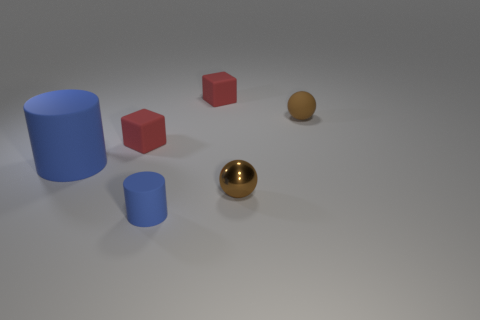Add 1 small brown shiny balls. How many objects exist? 7 Subtract all balls. How many objects are left? 4 Subtract all cylinders. Subtract all brown metal cylinders. How many objects are left? 4 Add 3 blocks. How many blocks are left? 5 Add 3 shiny cylinders. How many shiny cylinders exist? 3 Subtract 0 gray spheres. How many objects are left? 6 